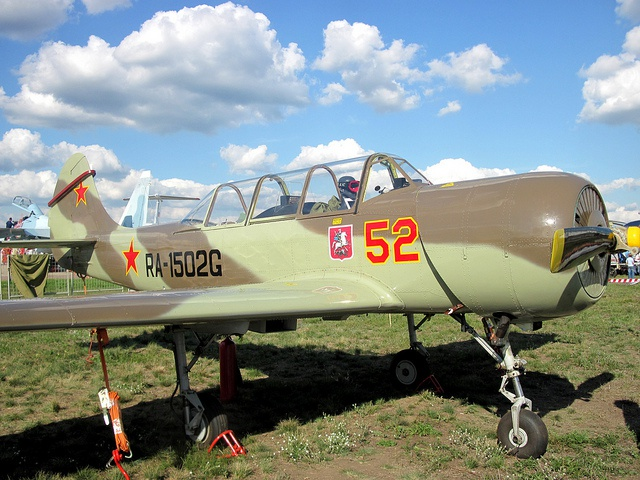Describe the objects in this image and their specific colors. I can see airplane in lightgray, gray, black, beige, and darkgray tones, people in lightgray, gray, darkgray, and navy tones, people in lightgray, white, gray, and darkgray tones, and people in lightgray, white, darkgray, and gray tones in this image. 